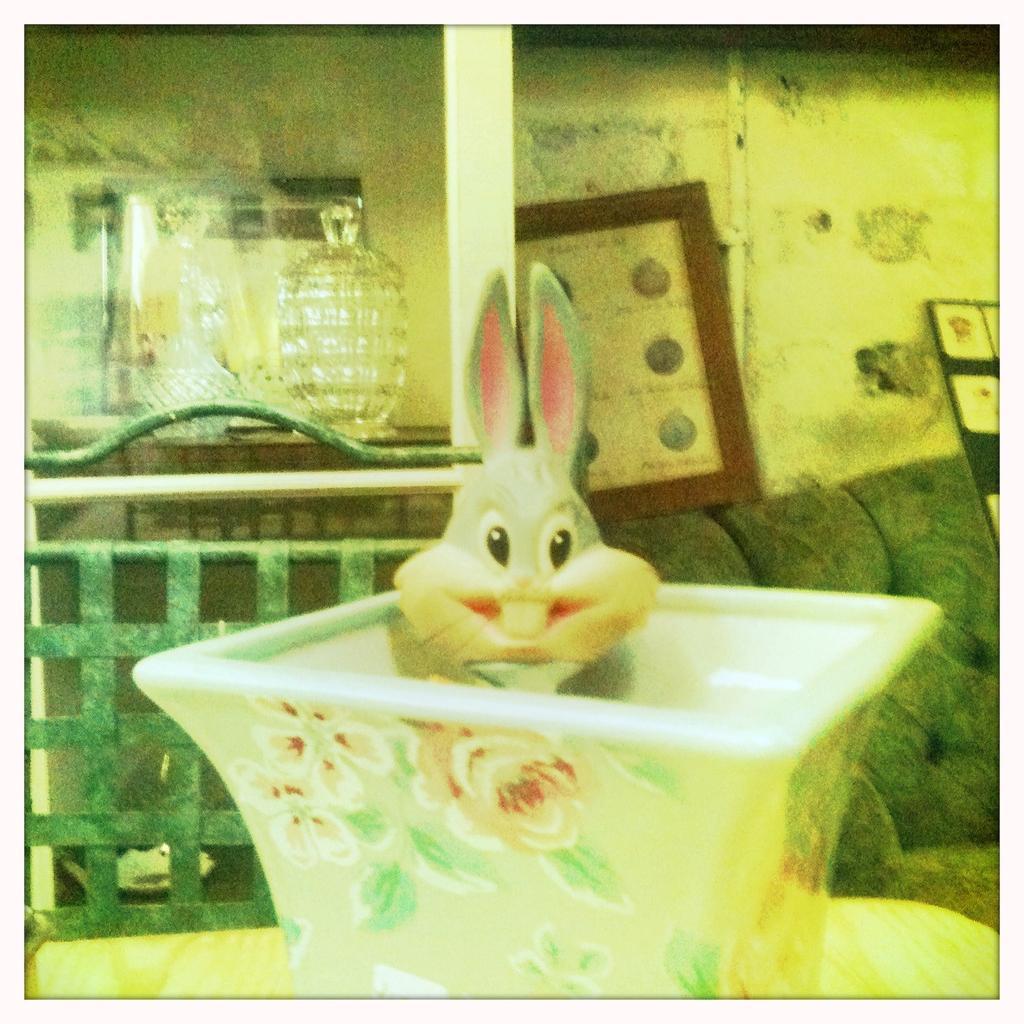Describe this image in one or two sentences. In this picture I can see a toy on the table and looks like a frame on the wall and I can see sofa and glass jars and a mirror and looks like a board with some posters on the right side of the picture. 